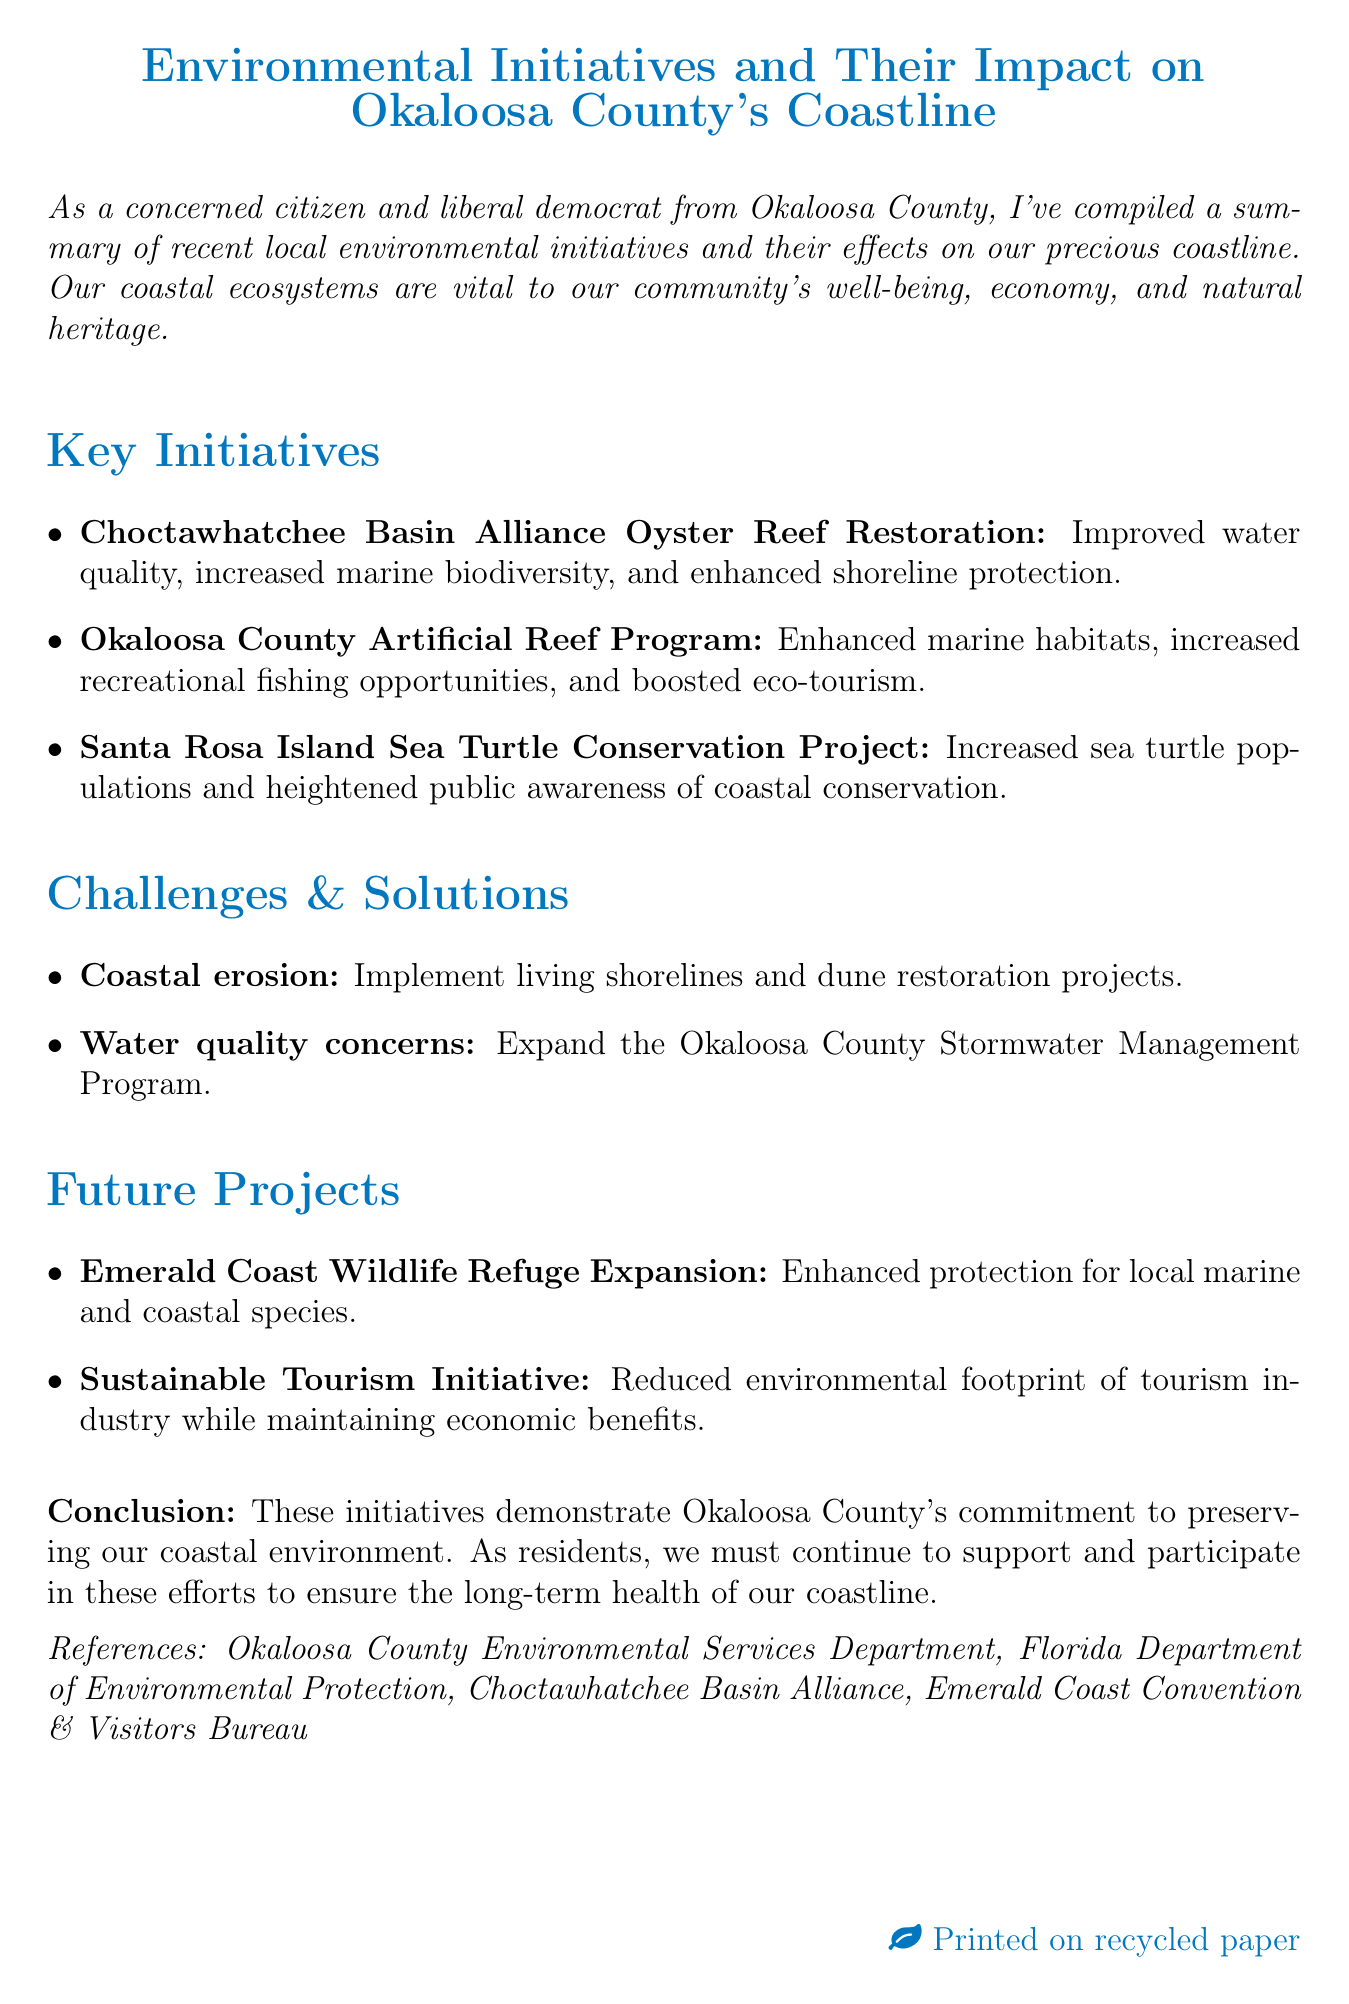what is the title of the memo? The title of the memo clearly states the subject it addresses.
Answer: Environmental Initiatives and Their Impact on Okaloosa County's Coastline what is one of the key benefits of the Choctawhatchee Basin Alliance Oyster Reef Restoration? The document specifies several impacts of this initiative.
Answer: Improved water quality what is the proposed solution for coastal erosion? The memo describes a specific response to a challenge mentioned.
Answer: Implementation of living shorelines and dune restoration projects how many future projects are mentioned in the memo? The document lists several projects, which indicates the number.
Answer: Two what is the potential impact of the Sustainable Tourism Initiative? The memo outlines the intended effects of future undertakings.
Answer: Reduced environmental footprint of tourism industry while maintaining economic benefits what is the name of the project aimed at protecting nesting sea turtles? The document gives a clear name for this conservation effort.
Answer: Santa Rosa Island Sea Turtle Conservation Project which organization is cited for its involvement in local environmental services? The memo provides specific references that indicate these organizations' roles.
Answer: Okaloosa County Environmental Services Department what common issue affects water quality according to the memo? The document elaborates on challenges faced regarding water quality.
Answer: Stormwater runoff and agricultural pollution what is the call to action in the conclusion of the memo? The conclusion encapsulates an appeal made to the community regarding future actions.
Answer: Support and participate in these efforts to ensure the long-term health of our coastline 